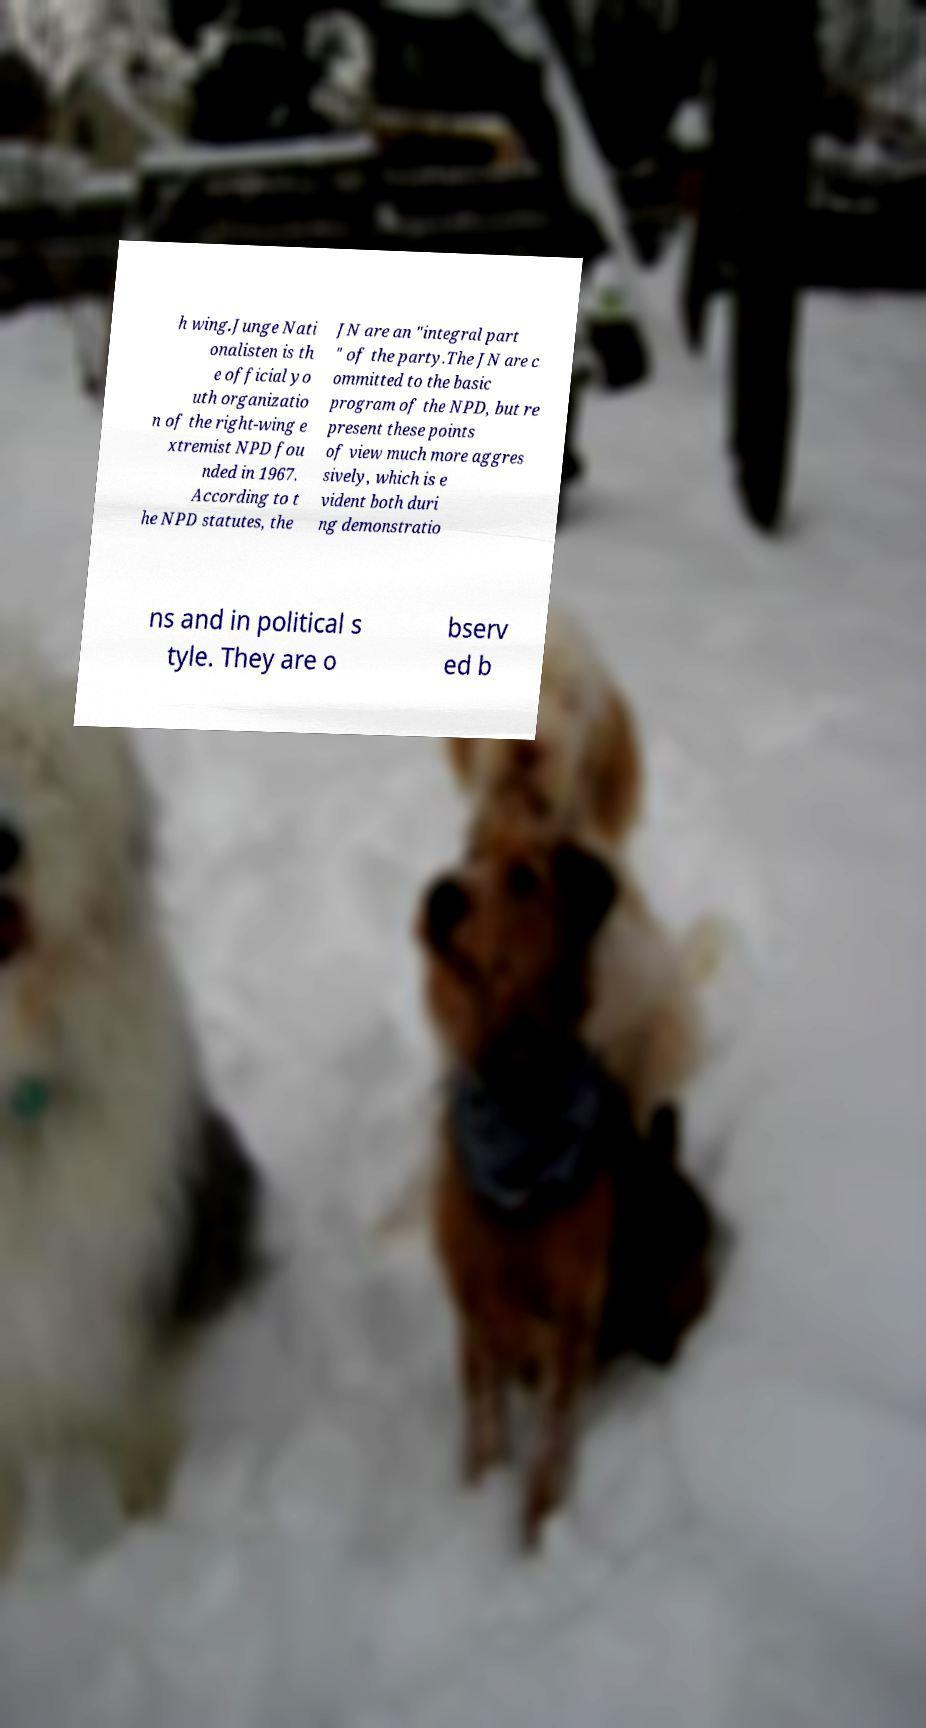Please read and relay the text visible in this image. What does it say? h wing.Junge Nati onalisten is th e official yo uth organizatio n of the right-wing e xtremist NPD fou nded in 1967. According to t he NPD statutes, the JN are an "integral part " of the party.The JN are c ommitted to the basic program of the NPD, but re present these points of view much more aggres sively, which is e vident both duri ng demonstratio ns and in political s tyle. They are o bserv ed b 